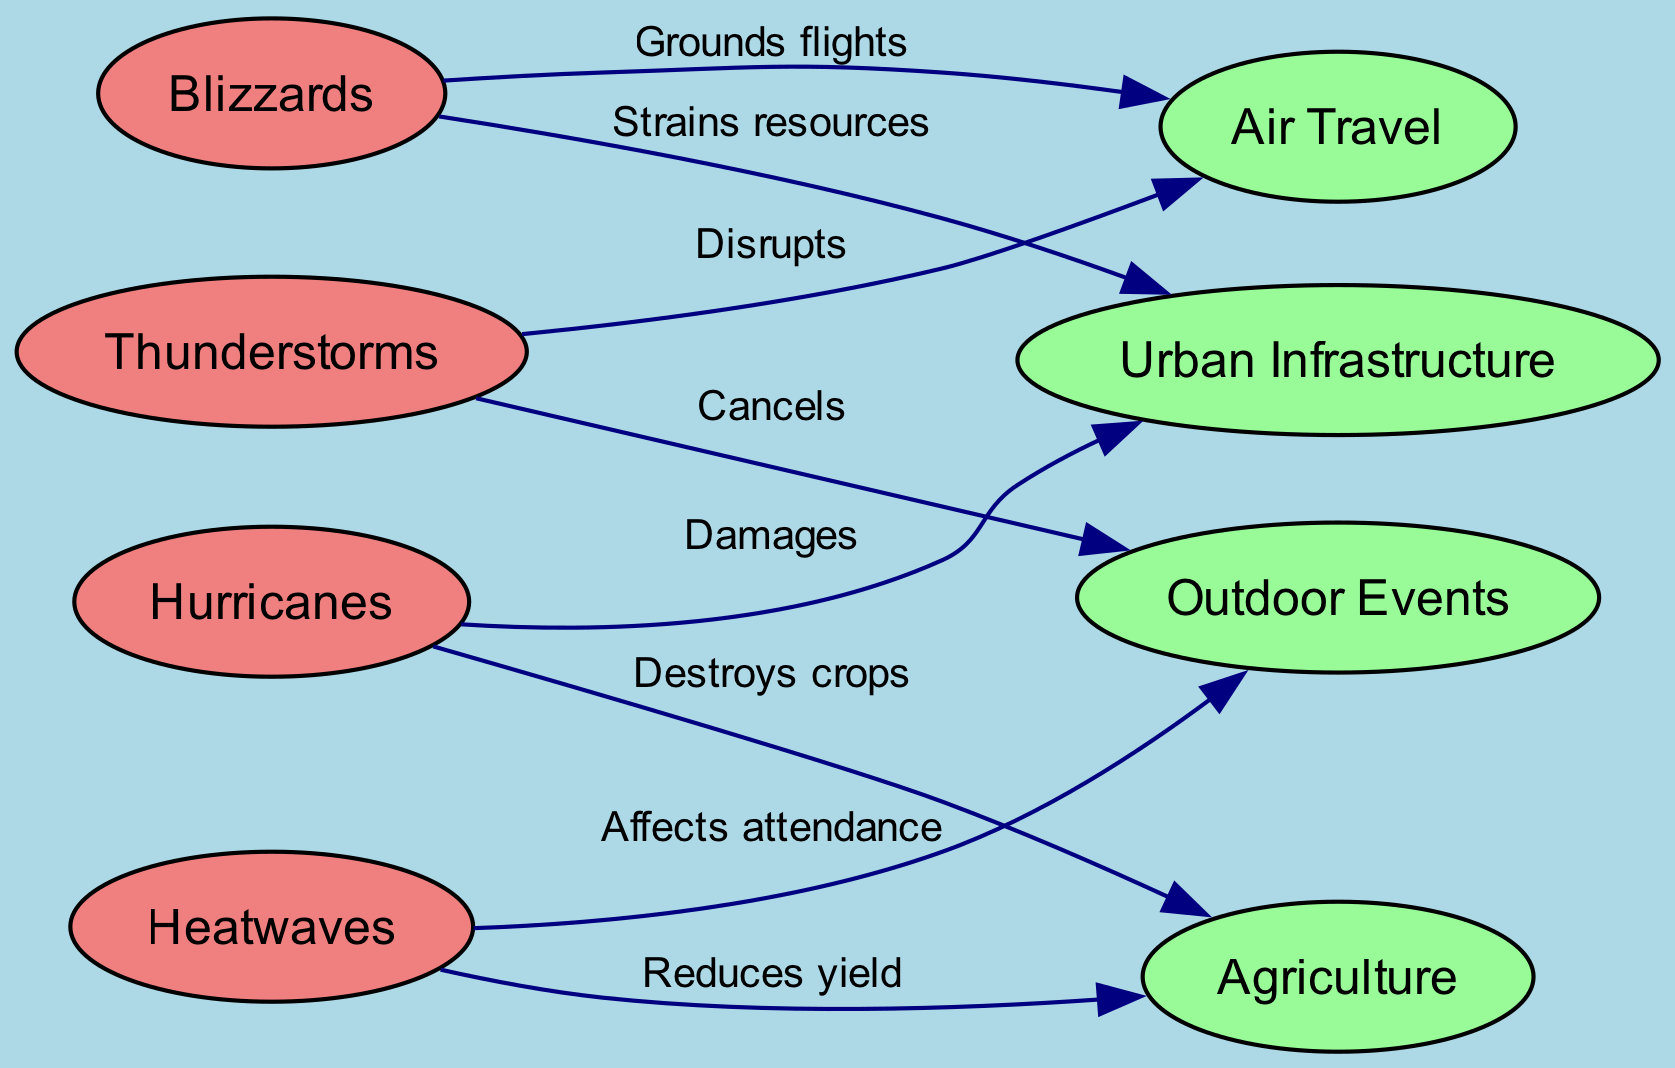What is the total number of nodes in the diagram? To find the total number of nodes, we need to count all distinct nodes listed in the "nodes" section of the data. There are 8 nodes labeled as Thunderstorms, Hurricanes, Heatwaves, Blizzards, Air Travel, Agriculture, Outdoor Events, and Urban Infrastructure.
Answer: 8 Which weather phenomenon causes the most disruptions to Air Travel? By examining the edges, we see that Thunderstorms and Blizzards both have a direct effect on Air Travel, but Thunderstorms specifically "Disrupt" Air Travel, while Blizzards "Ground" flights. Therefore, the most direct disruption comes from Thunderstorms.
Answer: Thunderstorms How many edges are associated with Agriculture? To determine the edges related to Agriculture, we look at the "edges" section. Agriculture is affected by Hurricanes (destroys crops) and Heatwaves (reduces yield). This confirms that there are 2 edges associated with Agriculture.
Answer: 2 What type of relationship do Hurricanes have with Urban Infrastructure? Investigating the edges connected to Urban Infrastructure reveals that Hurricanes "Damage" Urban Infrastructure. This describes a negative impact of Hurricanes on this human activity.
Answer: Damages Which weather phenomenon has the least direct impact on Outdoor Events? To find this, we assess the edges connecting to Outdoor Events. Thunderstorms "Cancel" outdoor events, and Heatwaves "Affect attendance." Heatwaves imply less of a direct impact compared to the outright cancellation by Thunderstorms, thus they have the least direct impact.
Answer: Heatwaves How many types of weather phenomena are represented in the diagram? By analyzing the "nodes" section, we find that there are 4 weather phenomena: Thunderstorms, Hurricanes, Heatwaves, and Blizzards. This indicates that the diagram captures 4 distinct types of weather phenomena.
Answer: 4 What human activity is not directly affected by Blizzards? Looking at the edges linked to Blizzards, we note impacts on Air Travel (grounds flights) and Urban Infrastructure (strains resources). The remaining activities, such as Outdoor Events and Agriculture, are not distinctly mentioned, making it clear that Agriculture is not directly affected.
Answer: Agriculture Which weather phenomenon affects attendance at Outdoor Events? By scanning the edges for any interactions with Outdoor Events, we find that Heatwaves "Affect attendance." Therefore, this phenomenon is responsible for the effect on attendance.
Answer: Heatwaves 